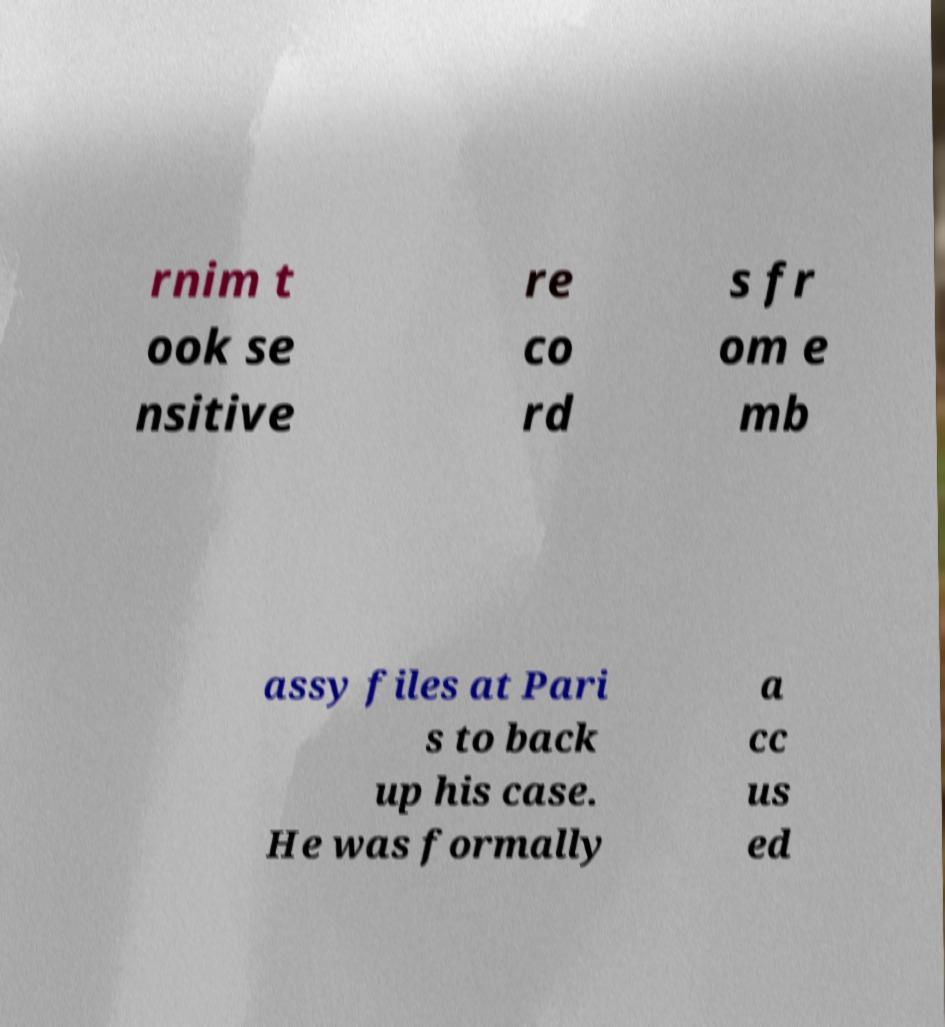What messages or text are displayed in this image? I need them in a readable, typed format. rnim t ook se nsitive re co rd s fr om e mb assy files at Pari s to back up his case. He was formally a cc us ed 